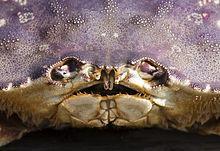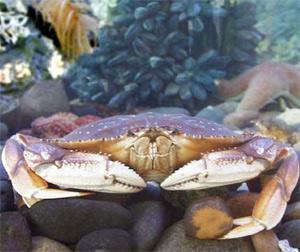The first image is the image on the left, the second image is the image on the right. Evaluate the accuracy of this statement regarding the images: "in at least one image there is a single carb facing forward in water with coral in the background.". Is it true? Answer yes or no. Yes. The first image is the image on the left, the second image is the image on the right. Examine the images to the left and right. Is the description "The right image shows the top view of a crab with a grainy grayish shell, and the left image shows at least one crab with a pinker shell and yellow-tinted claws." accurate? Answer yes or no. No. 